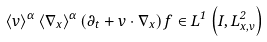<formula> <loc_0><loc_0><loc_500><loc_500>\left < v \right > ^ { \alpha } \left < \nabla _ { x } \right > ^ { \alpha } \left ( \partial _ { t } + v \cdot \nabla _ { x } \right ) f \in L ^ { 1 } \left ( I , L ^ { 2 } _ { x , v } \right )</formula> 